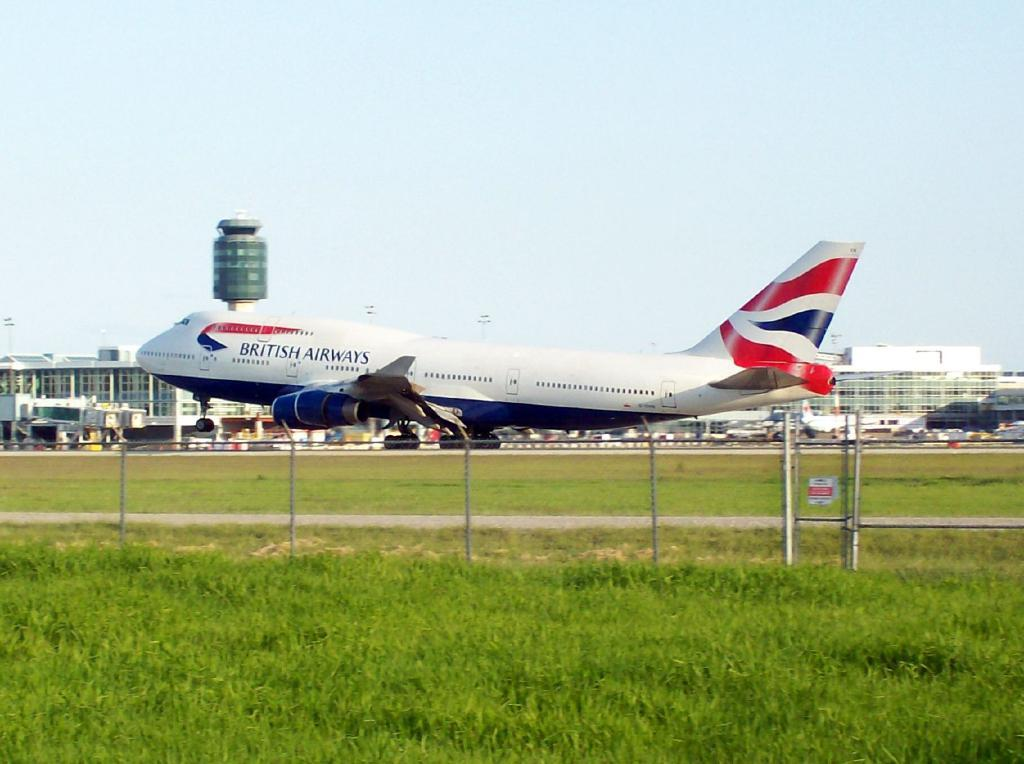What is the main subject in the center of the image? There is an aeroplane in the center of the image. What type of terrain is visible at the bottom of the image? There is grass and a fence at the bottom of the image. What can be seen in the background of the image? There are buildings and the sky visible in the background of the image. What type of oil can be seen dripping from the aeroplane in the image? There is no oil visible in the image, and the aeroplane is not depicted as dripping anything. 